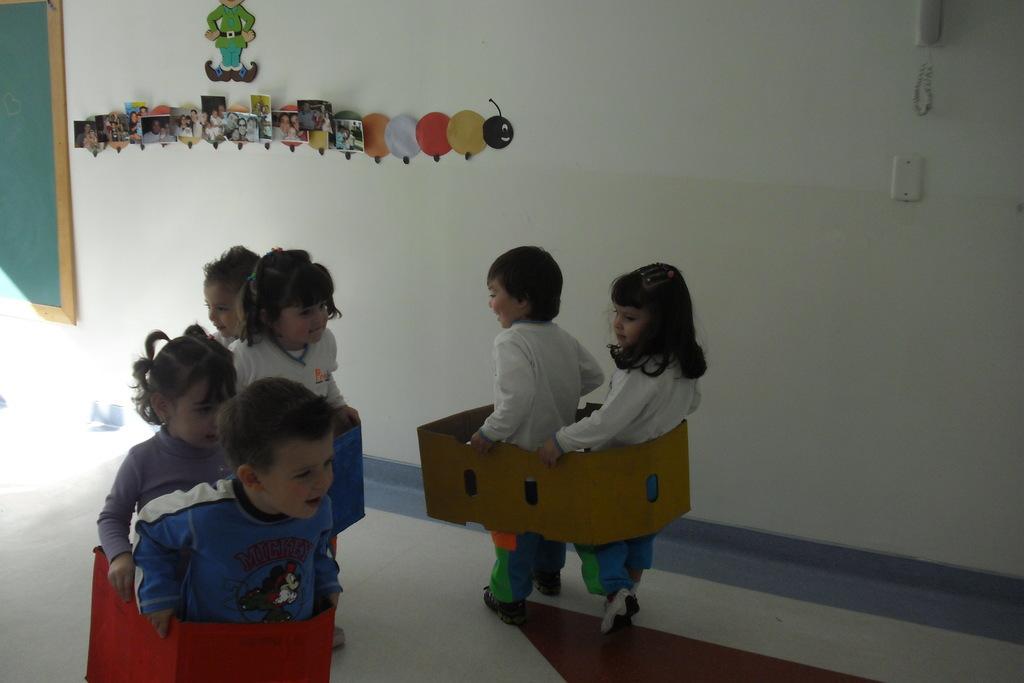Describe this image in one or two sentences. In this image there are a few kids walking by holding a cardboard box around them, in the background of the image there is a board and some photographs, balloons and some dolls on the wall and there is a telephone. 